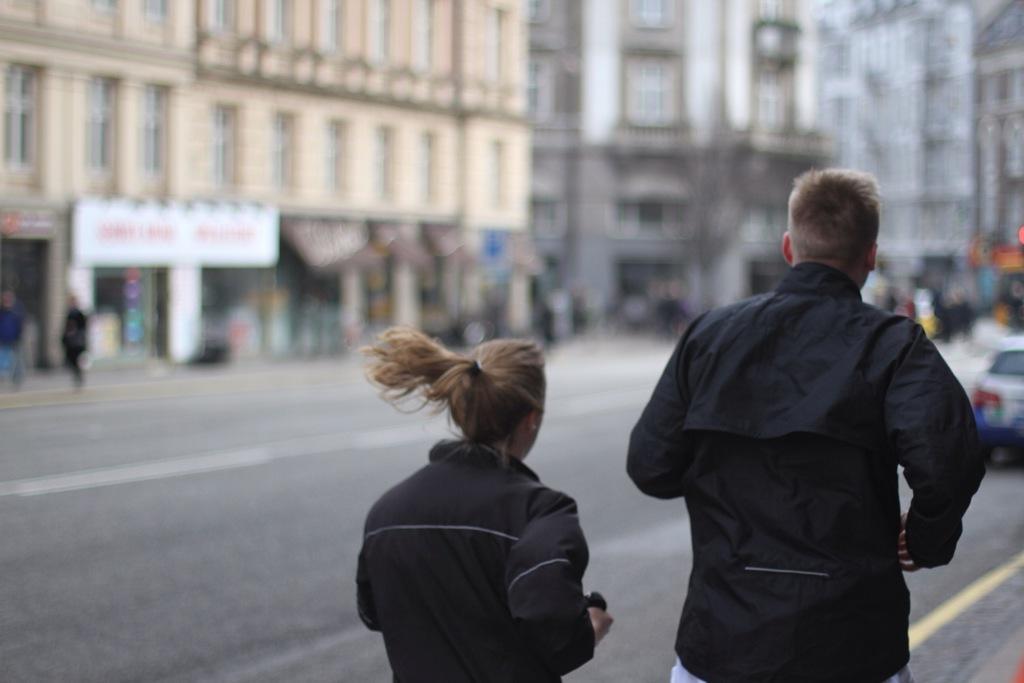Describe this image in one or two sentences. In this picture we can see two people, in front of them we can see buildings, people, vehicle and some objects and in the background we can see it is blurry. 